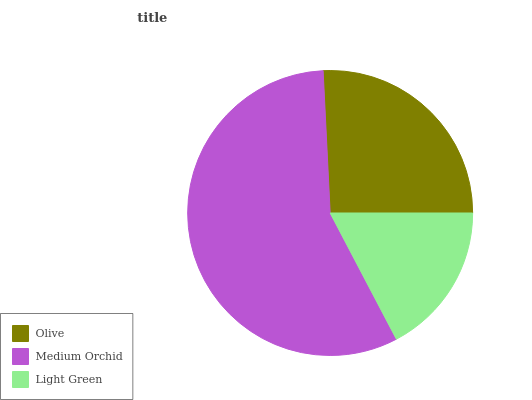Is Light Green the minimum?
Answer yes or no. Yes. Is Medium Orchid the maximum?
Answer yes or no. Yes. Is Medium Orchid the minimum?
Answer yes or no. No. Is Light Green the maximum?
Answer yes or no. No. Is Medium Orchid greater than Light Green?
Answer yes or no. Yes. Is Light Green less than Medium Orchid?
Answer yes or no. Yes. Is Light Green greater than Medium Orchid?
Answer yes or no. No. Is Medium Orchid less than Light Green?
Answer yes or no. No. Is Olive the high median?
Answer yes or no. Yes. Is Olive the low median?
Answer yes or no. Yes. Is Light Green the high median?
Answer yes or no. No. Is Medium Orchid the low median?
Answer yes or no. No. 